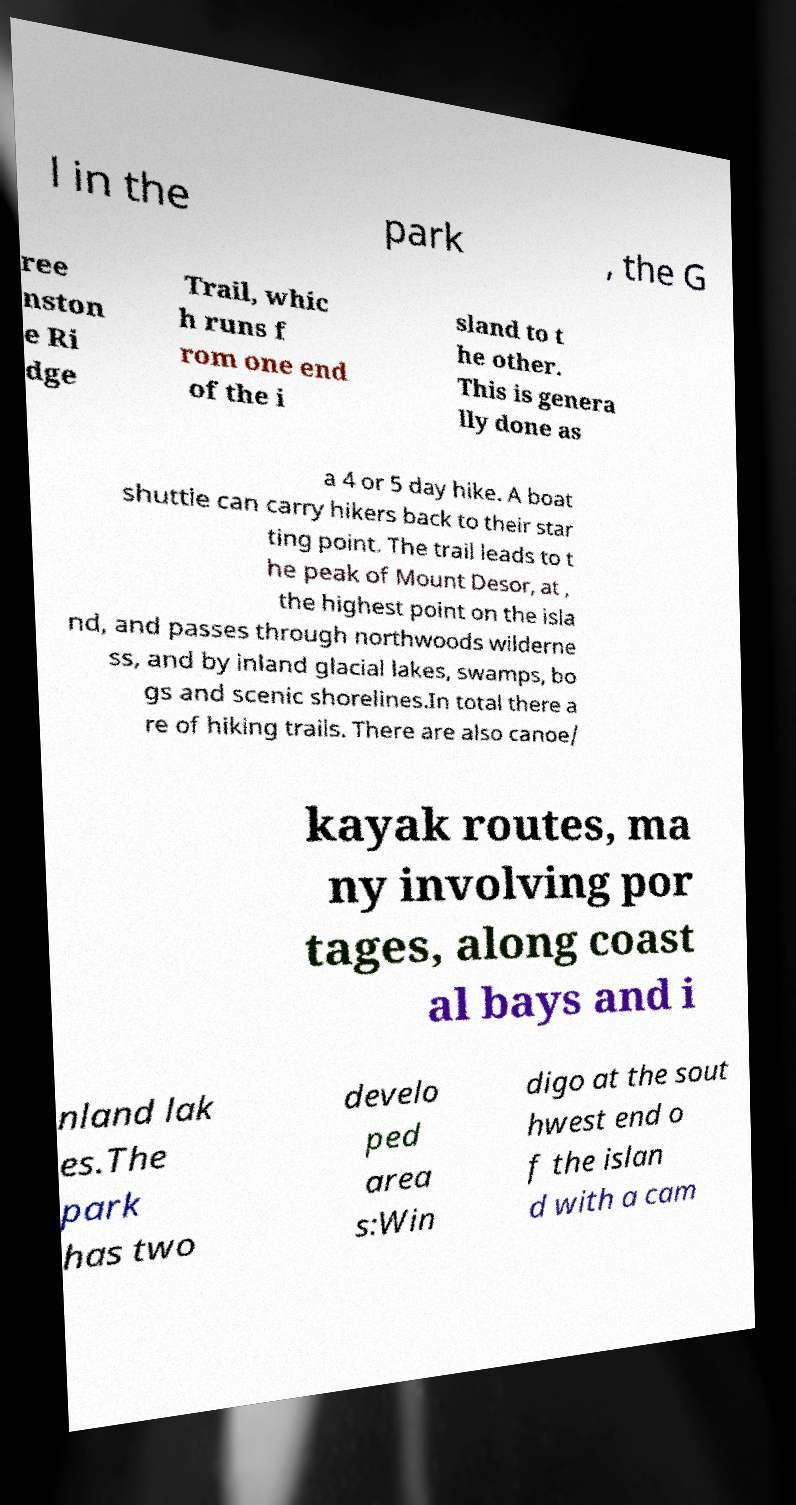Can you accurately transcribe the text from the provided image for me? l in the park , the G ree nston e Ri dge Trail, whic h runs f rom one end of the i sland to t he other. This is genera lly done as a 4 or 5 day hike. A boat shuttle can carry hikers back to their star ting point. The trail leads to t he peak of Mount Desor, at , the highest point on the isla nd, and passes through northwoods wilderne ss, and by inland glacial lakes, swamps, bo gs and scenic shorelines.In total there a re of hiking trails. There are also canoe/ kayak routes, ma ny involving por tages, along coast al bays and i nland lak es.The park has two develo ped area s:Win digo at the sout hwest end o f the islan d with a cam 